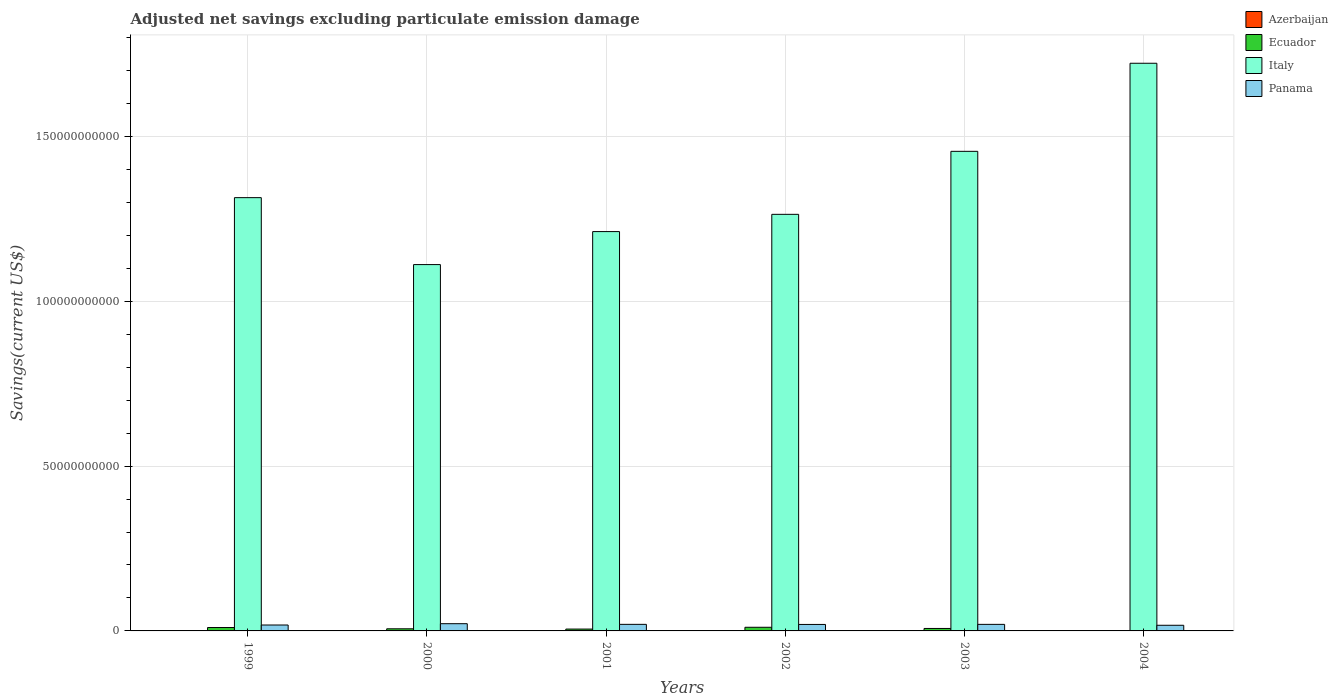How many different coloured bars are there?
Offer a very short reply. 3. How many groups of bars are there?
Offer a terse response. 6. Are the number of bars per tick equal to the number of legend labels?
Provide a succinct answer. No. How many bars are there on the 2nd tick from the right?
Make the answer very short. 3. What is the label of the 3rd group of bars from the left?
Give a very brief answer. 2001. Across all years, what is the maximum adjusted net savings in Panama?
Make the answer very short. 2.19e+09. Across all years, what is the minimum adjusted net savings in Panama?
Provide a short and direct response. 1.71e+09. In which year was the adjusted net savings in Ecuador maximum?
Offer a terse response. 2002. What is the total adjusted net savings in Italy in the graph?
Your response must be concise. 8.08e+11. What is the difference between the adjusted net savings in Ecuador in 2001 and that in 2002?
Give a very brief answer. -5.45e+08. What is the difference between the adjusted net savings in Italy in 2000 and the adjusted net savings in Azerbaijan in 1999?
Ensure brevity in your answer.  1.11e+11. What is the average adjusted net savings in Italy per year?
Keep it short and to the point. 1.35e+11. In the year 2004, what is the difference between the adjusted net savings in Italy and adjusted net savings in Panama?
Offer a terse response. 1.70e+11. What is the ratio of the adjusted net savings in Panama in 1999 to that in 2001?
Provide a short and direct response. 0.9. Is the adjusted net savings in Italy in 2001 less than that in 2002?
Your response must be concise. Yes. What is the difference between the highest and the second highest adjusted net savings in Ecuador?
Your answer should be very brief. 7.70e+07. What is the difference between the highest and the lowest adjusted net savings in Italy?
Your answer should be very brief. 6.11e+1. In how many years, is the adjusted net savings in Azerbaijan greater than the average adjusted net savings in Azerbaijan taken over all years?
Offer a terse response. 0. Is the sum of the adjusted net savings in Italy in 2003 and 2004 greater than the maximum adjusted net savings in Azerbaijan across all years?
Offer a very short reply. Yes. Is it the case that in every year, the sum of the adjusted net savings in Italy and adjusted net savings in Ecuador is greater than the sum of adjusted net savings in Panama and adjusted net savings in Azerbaijan?
Your answer should be compact. Yes. How many bars are there?
Your answer should be very brief. 17. How many legend labels are there?
Your answer should be very brief. 4. What is the title of the graph?
Your answer should be compact. Adjusted net savings excluding particulate emission damage. What is the label or title of the Y-axis?
Your answer should be compact. Savings(current US$). What is the Savings(current US$) of Ecuador in 1999?
Provide a short and direct response. 1.03e+09. What is the Savings(current US$) in Italy in 1999?
Give a very brief answer. 1.31e+11. What is the Savings(current US$) in Panama in 1999?
Your response must be concise. 1.79e+09. What is the Savings(current US$) in Ecuador in 2000?
Offer a terse response. 6.41e+08. What is the Savings(current US$) in Italy in 2000?
Offer a very short reply. 1.11e+11. What is the Savings(current US$) in Panama in 2000?
Offer a very short reply. 2.19e+09. What is the Savings(current US$) in Ecuador in 2001?
Provide a succinct answer. 5.61e+08. What is the Savings(current US$) in Italy in 2001?
Provide a succinct answer. 1.21e+11. What is the Savings(current US$) of Panama in 2001?
Ensure brevity in your answer.  1.99e+09. What is the Savings(current US$) of Ecuador in 2002?
Keep it short and to the point. 1.11e+09. What is the Savings(current US$) in Italy in 2002?
Provide a short and direct response. 1.26e+11. What is the Savings(current US$) in Panama in 2002?
Offer a very short reply. 1.97e+09. What is the Savings(current US$) of Ecuador in 2003?
Give a very brief answer. 7.47e+08. What is the Savings(current US$) of Italy in 2003?
Your answer should be compact. 1.45e+11. What is the Savings(current US$) in Panama in 2003?
Give a very brief answer. 1.99e+09. What is the Savings(current US$) of Azerbaijan in 2004?
Make the answer very short. 0. What is the Savings(current US$) in Ecuador in 2004?
Your answer should be compact. 0. What is the Savings(current US$) of Italy in 2004?
Ensure brevity in your answer.  1.72e+11. What is the Savings(current US$) of Panama in 2004?
Provide a short and direct response. 1.71e+09. Across all years, what is the maximum Savings(current US$) in Ecuador?
Make the answer very short. 1.11e+09. Across all years, what is the maximum Savings(current US$) in Italy?
Offer a terse response. 1.72e+11. Across all years, what is the maximum Savings(current US$) in Panama?
Your answer should be compact. 2.19e+09. Across all years, what is the minimum Savings(current US$) of Ecuador?
Keep it short and to the point. 0. Across all years, what is the minimum Savings(current US$) of Italy?
Keep it short and to the point. 1.11e+11. Across all years, what is the minimum Savings(current US$) of Panama?
Give a very brief answer. 1.71e+09. What is the total Savings(current US$) in Azerbaijan in the graph?
Your answer should be very brief. 0. What is the total Savings(current US$) of Ecuador in the graph?
Your answer should be compact. 4.08e+09. What is the total Savings(current US$) in Italy in the graph?
Your response must be concise. 8.08e+11. What is the total Savings(current US$) in Panama in the graph?
Keep it short and to the point. 1.16e+1. What is the difference between the Savings(current US$) of Ecuador in 1999 and that in 2000?
Ensure brevity in your answer.  3.88e+08. What is the difference between the Savings(current US$) of Italy in 1999 and that in 2000?
Provide a succinct answer. 2.03e+1. What is the difference between the Savings(current US$) in Panama in 1999 and that in 2000?
Your answer should be compact. -4.00e+08. What is the difference between the Savings(current US$) in Ecuador in 1999 and that in 2001?
Provide a short and direct response. 4.68e+08. What is the difference between the Savings(current US$) of Italy in 1999 and that in 2001?
Your answer should be very brief. 1.03e+1. What is the difference between the Savings(current US$) in Panama in 1999 and that in 2001?
Offer a very short reply. -2.02e+08. What is the difference between the Savings(current US$) of Ecuador in 1999 and that in 2002?
Your answer should be compact. -7.70e+07. What is the difference between the Savings(current US$) of Italy in 1999 and that in 2002?
Your answer should be compact. 5.06e+09. What is the difference between the Savings(current US$) of Panama in 1999 and that in 2002?
Give a very brief answer. -1.74e+08. What is the difference between the Savings(current US$) of Ecuador in 1999 and that in 2003?
Make the answer very short. 2.83e+08. What is the difference between the Savings(current US$) in Italy in 1999 and that in 2003?
Keep it short and to the point. -1.40e+1. What is the difference between the Savings(current US$) of Panama in 1999 and that in 2003?
Ensure brevity in your answer.  -1.96e+08. What is the difference between the Savings(current US$) in Italy in 1999 and that in 2004?
Your answer should be very brief. -4.08e+1. What is the difference between the Savings(current US$) of Panama in 1999 and that in 2004?
Provide a short and direct response. 7.98e+07. What is the difference between the Savings(current US$) in Ecuador in 2000 and that in 2001?
Provide a short and direct response. 8.04e+07. What is the difference between the Savings(current US$) in Italy in 2000 and that in 2001?
Provide a succinct answer. -1.00e+1. What is the difference between the Savings(current US$) in Panama in 2000 and that in 2001?
Ensure brevity in your answer.  1.97e+08. What is the difference between the Savings(current US$) in Ecuador in 2000 and that in 2002?
Give a very brief answer. -4.65e+08. What is the difference between the Savings(current US$) in Italy in 2000 and that in 2002?
Offer a very short reply. -1.52e+1. What is the difference between the Savings(current US$) of Panama in 2000 and that in 2002?
Offer a terse response. 2.26e+08. What is the difference between the Savings(current US$) of Ecuador in 2000 and that in 2003?
Ensure brevity in your answer.  -1.05e+08. What is the difference between the Savings(current US$) of Italy in 2000 and that in 2003?
Your answer should be very brief. -3.44e+1. What is the difference between the Savings(current US$) of Panama in 2000 and that in 2003?
Offer a very short reply. 2.03e+08. What is the difference between the Savings(current US$) of Italy in 2000 and that in 2004?
Your response must be concise. -6.11e+1. What is the difference between the Savings(current US$) of Panama in 2000 and that in 2004?
Offer a very short reply. 4.79e+08. What is the difference between the Savings(current US$) of Ecuador in 2001 and that in 2002?
Your answer should be very brief. -5.45e+08. What is the difference between the Savings(current US$) in Italy in 2001 and that in 2002?
Ensure brevity in your answer.  -5.23e+09. What is the difference between the Savings(current US$) of Panama in 2001 and that in 2002?
Your answer should be compact. 2.83e+07. What is the difference between the Savings(current US$) of Ecuador in 2001 and that in 2003?
Offer a terse response. -1.85e+08. What is the difference between the Savings(current US$) of Italy in 2001 and that in 2003?
Your answer should be very brief. -2.43e+1. What is the difference between the Savings(current US$) in Panama in 2001 and that in 2003?
Provide a short and direct response. 5.92e+06. What is the difference between the Savings(current US$) in Italy in 2001 and that in 2004?
Give a very brief answer. -5.11e+1. What is the difference between the Savings(current US$) of Panama in 2001 and that in 2004?
Your response must be concise. 2.82e+08. What is the difference between the Savings(current US$) of Ecuador in 2002 and that in 2003?
Keep it short and to the point. 3.60e+08. What is the difference between the Savings(current US$) in Italy in 2002 and that in 2003?
Offer a terse response. -1.91e+1. What is the difference between the Savings(current US$) in Panama in 2002 and that in 2003?
Keep it short and to the point. -2.24e+07. What is the difference between the Savings(current US$) of Italy in 2002 and that in 2004?
Keep it short and to the point. -4.58e+1. What is the difference between the Savings(current US$) of Panama in 2002 and that in 2004?
Your response must be concise. 2.54e+08. What is the difference between the Savings(current US$) in Italy in 2003 and that in 2004?
Your answer should be very brief. -2.67e+1. What is the difference between the Savings(current US$) of Panama in 2003 and that in 2004?
Provide a succinct answer. 2.76e+08. What is the difference between the Savings(current US$) of Ecuador in 1999 and the Savings(current US$) of Italy in 2000?
Offer a terse response. -1.10e+11. What is the difference between the Savings(current US$) in Ecuador in 1999 and the Savings(current US$) in Panama in 2000?
Your answer should be very brief. -1.16e+09. What is the difference between the Savings(current US$) in Italy in 1999 and the Savings(current US$) in Panama in 2000?
Your response must be concise. 1.29e+11. What is the difference between the Savings(current US$) in Ecuador in 1999 and the Savings(current US$) in Italy in 2001?
Offer a terse response. -1.20e+11. What is the difference between the Savings(current US$) of Ecuador in 1999 and the Savings(current US$) of Panama in 2001?
Your response must be concise. -9.65e+08. What is the difference between the Savings(current US$) of Italy in 1999 and the Savings(current US$) of Panama in 2001?
Offer a very short reply. 1.29e+11. What is the difference between the Savings(current US$) of Ecuador in 1999 and the Savings(current US$) of Italy in 2002?
Offer a terse response. -1.25e+11. What is the difference between the Savings(current US$) of Ecuador in 1999 and the Savings(current US$) of Panama in 2002?
Your answer should be very brief. -9.36e+08. What is the difference between the Savings(current US$) in Italy in 1999 and the Savings(current US$) in Panama in 2002?
Keep it short and to the point. 1.29e+11. What is the difference between the Savings(current US$) in Ecuador in 1999 and the Savings(current US$) in Italy in 2003?
Keep it short and to the point. -1.44e+11. What is the difference between the Savings(current US$) in Ecuador in 1999 and the Savings(current US$) in Panama in 2003?
Your answer should be compact. -9.59e+08. What is the difference between the Savings(current US$) in Italy in 1999 and the Savings(current US$) in Panama in 2003?
Offer a very short reply. 1.29e+11. What is the difference between the Savings(current US$) in Ecuador in 1999 and the Savings(current US$) in Italy in 2004?
Your answer should be compact. -1.71e+11. What is the difference between the Savings(current US$) of Ecuador in 1999 and the Savings(current US$) of Panama in 2004?
Your answer should be very brief. -6.83e+08. What is the difference between the Savings(current US$) of Italy in 1999 and the Savings(current US$) of Panama in 2004?
Keep it short and to the point. 1.30e+11. What is the difference between the Savings(current US$) in Ecuador in 2000 and the Savings(current US$) in Italy in 2001?
Offer a terse response. -1.20e+11. What is the difference between the Savings(current US$) in Ecuador in 2000 and the Savings(current US$) in Panama in 2001?
Make the answer very short. -1.35e+09. What is the difference between the Savings(current US$) of Italy in 2000 and the Savings(current US$) of Panama in 2001?
Your answer should be compact. 1.09e+11. What is the difference between the Savings(current US$) of Ecuador in 2000 and the Savings(current US$) of Italy in 2002?
Give a very brief answer. -1.26e+11. What is the difference between the Savings(current US$) in Ecuador in 2000 and the Savings(current US$) in Panama in 2002?
Provide a succinct answer. -1.32e+09. What is the difference between the Savings(current US$) of Italy in 2000 and the Savings(current US$) of Panama in 2002?
Give a very brief answer. 1.09e+11. What is the difference between the Savings(current US$) in Ecuador in 2000 and the Savings(current US$) in Italy in 2003?
Your answer should be very brief. -1.45e+11. What is the difference between the Savings(current US$) of Ecuador in 2000 and the Savings(current US$) of Panama in 2003?
Your answer should be compact. -1.35e+09. What is the difference between the Savings(current US$) in Italy in 2000 and the Savings(current US$) in Panama in 2003?
Provide a succinct answer. 1.09e+11. What is the difference between the Savings(current US$) of Ecuador in 2000 and the Savings(current US$) of Italy in 2004?
Ensure brevity in your answer.  -1.72e+11. What is the difference between the Savings(current US$) in Ecuador in 2000 and the Savings(current US$) in Panama in 2004?
Offer a terse response. -1.07e+09. What is the difference between the Savings(current US$) of Italy in 2000 and the Savings(current US$) of Panama in 2004?
Make the answer very short. 1.09e+11. What is the difference between the Savings(current US$) in Ecuador in 2001 and the Savings(current US$) in Italy in 2002?
Your answer should be compact. -1.26e+11. What is the difference between the Savings(current US$) of Ecuador in 2001 and the Savings(current US$) of Panama in 2002?
Provide a short and direct response. -1.40e+09. What is the difference between the Savings(current US$) of Italy in 2001 and the Savings(current US$) of Panama in 2002?
Your answer should be very brief. 1.19e+11. What is the difference between the Savings(current US$) of Ecuador in 2001 and the Savings(current US$) of Italy in 2003?
Provide a succinct answer. -1.45e+11. What is the difference between the Savings(current US$) of Ecuador in 2001 and the Savings(current US$) of Panama in 2003?
Your answer should be very brief. -1.43e+09. What is the difference between the Savings(current US$) in Italy in 2001 and the Savings(current US$) in Panama in 2003?
Offer a very short reply. 1.19e+11. What is the difference between the Savings(current US$) in Ecuador in 2001 and the Savings(current US$) in Italy in 2004?
Your answer should be compact. -1.72e+11. What is the difference between the Savings(current US$) of Ecuador in 2001 and the Savings(current US$) of Panama in 2004?
Ensure brevity in your answer.  -1.15e+09. What is the difference between the Savings(current US$) of Italy in 2001 and the Savings(current US$) of Panama in 2004?
Keep it short and to the point. 1.19e+11. What is the difference between the Savings(current US$) of Ecuador in 2002 and the Savings(current US$) of Italy in 2003?
Offer a very short reply. -1.44e+11. What is the difference between the Savings(current US$) in Ecuador in 2002 and the Savings(current US$) in Panama in 2003?
Offer a terse response. -8.82e+08. What is the difference between the Savings(current US$) in Italy in 2002 and the Savings(current US$) in Panama in 2003?
Provide a short and direct response. 1.24e+11. What is the difference between the Savings(current US$) in Ecuador in 2002 and the Savings(current US$) in Italy in 2004?
Offer a very short reply. -1.71e+11. What is the difference between the Savings(current US$) of Ecuador in 2002 and the Savings(current US$) of Panama in 2004?
Make the answer very short. -6.06e+08. What is the difference between the Savings(current US$) in Italy in 2002 and the Savings(current US$) in Panama in 2004?
Keep it short and to the point. 1.25e+11. What is the difference between the Savings(current US$) in Ecuador in 2003 and the Savings(current US$) in Italy in 2004?
Make the answer very short. -1.71e+11. What is the difference between the Savings(current US$) in Ecuador in 2003 and the Savings(current US$) in Panama in 2004?
Your answer should be compact. -9.66e+08. What is the difference between the Savings(current US$) of Italy in 2003 and the Savings(current US$) of Panama in 2004?
Provide a succinct answer. 1.44e+11. What is the average Savings(current US$) in Ecuador per year?
Provide a short and direct response. 6.81e+08. What is the average Savings(current US$) in Italy per year?
Your answer should be very brief. 1.35e+11. What is the average Savings(current US$) of Panama per year?
Provide a short and direct response. 1.94e+09. In the year 1999, what is the difference between the Savings(current US$) in Ecuador and Savings(current US$) in Italy?
Give a very brief answer. -1.30e+11. In the year 1999, what is the difference between the Savings(current US$) in Ecuador and Savings(current US$) in Panama?
Offer a terse response. -7.63e+08. In the year 1999, what is the difference between the Savings(current US$) of Italy and Savings(current US$) of Panama?
Provide a succinct answer. 1.30e+11. In the year 2000, what is the difference between the Savings(current US$) in Ecuador and Savings(current US$) in Italy?
Offer a very short reply. -1.10e+11. In the year 2000, what is the difference between the Savings(current US$) of Ecuador and Savings(current US$) of Panama?
Make the answer very short. -1.55e+09. In the year 2000, what is the difference between the Savings(current US$) of Italy and Savings(current US$) of Panama?
Give a very brief answer. 1.09e+11. In the year 2001, what is the difference between the Savings(current US$) in Ecuador and Savings(current US$) in Italy?
Offer a very short reply. -1.21e+11. In the year 2001, what is the difference between the Savings(current US$) in Ecuador and Savings(current US$) in Panama?
Your answer should be very brief. -1.43e+09. In the year 2001, what is the difference between the Savings(current US$) in Italy and Savings(current US$) in Panama?
Your response must be concise. 1.19e+11. In the year 2002, what is the difference between the Savings(current US$) of Ecuador and Savings(current US$) of Italy?
Make the answer very short. -1.25e+11. In the year 2002, what is the difference between the Savings(current US$) in Ecuador and Savings(current US$) in Panama?
Provide a short and direct response. -8.59e+08. In the year 2002, what is the difference between the Savings(current US$) in Italy and Savings(current US$) in Panama?
Ensure brevity in your answer.  1.24e+11. In the year 2003, what is the difference between the Savings(current US$) of Ecuador and Savings(current US$) of Italy?
Your response must be concise. -1.45e+11. In the year 2003, what is the difference between the Savings(current US$) in Ecuador and Savings(current US$) in Panama?
Your answer should be very brief. -1.24e+09. In the year 2003, what is the difference between the Savings(current US$) in Italy and Savings(current US$) in Panama?
Keep it short and to the point. 1.43e+11. In the year 2004, what is the difference between the Savings(current US$) in Italy and Savings(current US$) in Panama?
Your response must be concise. 1.70e+11. What is the ratio of the Savings(current US$) in Ecuador in 1999 to that in 2000?
Offer a terse response. 1.6. What is the ratio of the Savings(current US$) of Italy in 1999 to that in 2000?
Your answer should be very brief. 1.18. What is the ratio of the Savings(current US$) of Panama in 1999 to that in 2000?
Provide a short and direct response. 0.82. What is the ratio of the Savings(current US$) of Ecuador in 1999 to that in 2001?
Provide a succinct answer. 1.83. What is the ratio of the Savings(current US$) of Italy in 1999 to that in 2001?
Provide a succinct answer. 1.08. What is the ratio of the Savings(current US$) of Panama in 1999 to that in 2001?
Give a very brief answer. 0.9. What is the ratio of the Savings(current US$) of Ecuador in 1999 to that in 2002?
Offer a terse response. 0.93. What is the ratio of the Savings(current US$) in Italy in 1999 to that in 2002?
Ensure brevity in your answer.  1.04. What is the ratio of the Savings(current US$) of Panama in 1999 to that in 2002?
Give a very brief answer. 0.91. What is the ratio of the Savings(current US$) of Ecuador in 1999 to that in 2003?
Provide a short and direct response. 1.38. What is the ratio of the Savings(current US$) in Italy in 1999 to that in 2003?
Your response must be concise. 0.9. What is the ratio of the Savings(current US$) of Panama in 1999 to that in 2003?
Make the answer very short. 0.9. What is the ratio of the Savings(current US$) of Italy in 1999 to that in 2004?
Your response must be concise. 0.76. What is the ratio of the Savings(current US$) in Panama in 1999 to that in 2004?
Provide a succinct answer. 1.05. What is the ratio of the Savings(current US$) of Ecuador in 2000 to that in 2001?
Your answer should be compact. 1.14. What is the ratio of the Savings(current US$) of Italy in 2000 to that in 2001?
Keep it short and to the point. 0.92. What is the ratio of the Savings(current US$) of Panama in 2000 to that in 2001?
Ensure brevity in your answer.  1.1. What is the ratio of the Savings(current US$) of Ecuador in 2000 to that in 2002?
Your response must be concise. 0.58. What is the ratio of the Savings(current US$) in Italy in 2000 to that in 2002?
Provide a succinct answer. 0.88. What is the ratio of the Savings(current US$) in Panama in 2000 to that in 2002?
Make the answer very short. 1.11. What is the ratio of the Savings(current US$) in Ecuador in 2000 to that in 2003?
Offer a terse response. 0.86. What is the ratio of the Savings(current US$) of Italy in 2000 to that in 2003?
Provide a short and direct response. 0.76. What is the ratio of the Savings(current US$) of Panama in 2000 to that in 2003?
Your answer should be very brief. 1.1. What is the ratio of the Savings(current US$) in Italy in 2000 to that in 2004?
Provide a succinct answer. 0.65. What is the ratio of the Savings(current US$) of Panama in 2000 to that in 2004?
Provide a short and direct response. 1.28. What is the ratio of the Savings(current US$) in Ecuador in 2001 to that in 2002?
Keep it short and to the point. 0.51. What is the ratio of the Savings(current US$) of Italy in 2001 to that in 2002?
Provide a succinct answer. 0.96. What is the ratio of the Savings(current US$) in Panama in 2001 to that in 2002?
Give a very brief answer. 1.01. What is the ratio of the Savings(current US$) in Ecuador in 2001 to that in 2003?
Offer a very short reply. 0.75. What is the ratio of the Savings(current US$) in Italy in 2001 to that in 2003?
Ensure brevity in your answer.  0.83. What is the ratio of the Savings(current US$) in Italy in 2001 to that in 2004?
Provide a succinct answer. 0.7. What is the ratio of the Savings(current US$) of Panama in 2001 to that in 2004?
Give a very brief answer. 1.16. What is the ratio of the Savings(current US$) of Ecuador in 2002 to that in 2003?
Your answer should be very brief. 1.48. What is the ratio of the Savings(current US$) of Italy in 2002 to that in 2003?
Keep it short and to the point. 0.87. What is the ratio of the Savings(current US$) in Panama in 2002 to that in 2003?
Make the answer very short. 0.99. What is the ratio of the Savings(current US$) of Italy in 2002 to that in 2004?
Ensure brevity in your answer.  0.73. What is the ratio of the Savings(current US$) in Panama in 2002 to that in 2004?
Give a very brief answer. 1.15. What is the ratio of the Savings(current US$) in Italy in 2003 to that in 2004?
Make the answer very short. 0.84. What is the ratio of the Savings(current US$) in Panama in 2003 to that in 2004?
Your response must be concise. 1.16. What is the difference between the highest and the second highest Savings(current US$) of Ecuador?
Give a very brief answer. 7.70e+07. What is the difference between the highest and the second highest Savings(current US$) of Italy?
Make the answer very short. 2.67e+1. What is the difference between the highest and the second highest Savings(current US$) of Panama?
Provide a succinct answer. 1.97e+08. What is the difference between the highest and the lowest Savings(current US$) of Ecuador?
Your answer should be very brief. 1.11e+09. What is the difference between the highest and the lowest Savings(current US$) in Italy?
Give a very brief answer. 6.11e+1. What is the difference between the highest and the lowest Savings(current US$) of Panama?
Keep it short and to the point. 4.79e+08. 